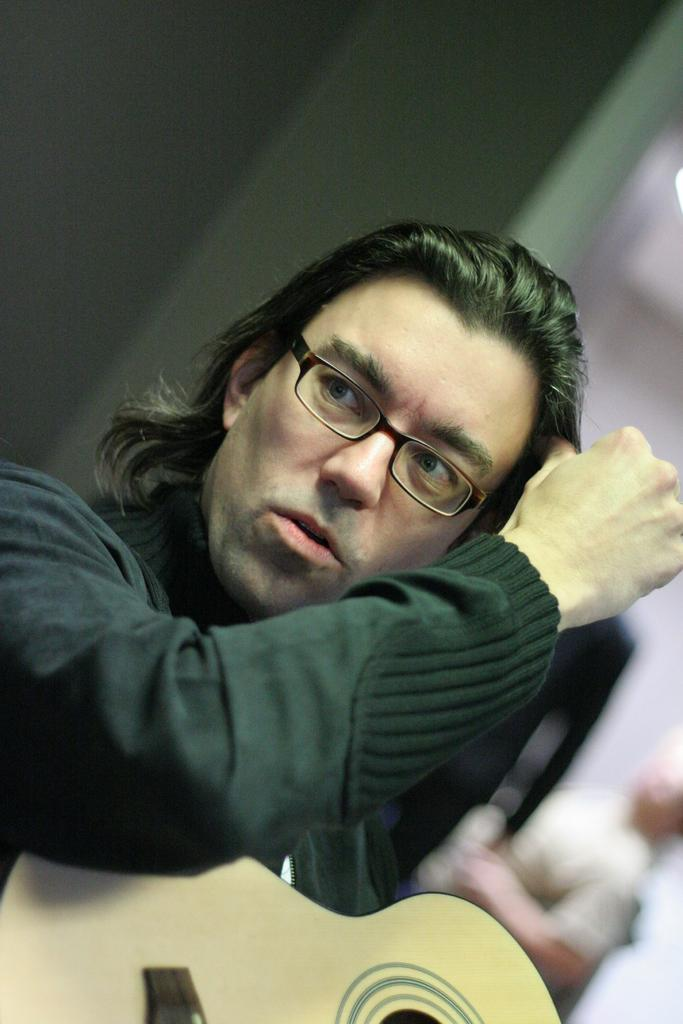Who is the main subject in the image? There is a man in the image. What is the man doing in the image? The man is seated in the image. What object is the man holding in the image? The man is holding a guitar in the image. What accessory is the man wearing in the image? The man is wearing spectacles in the image. What color is the shirt the man is wearing in the image? The man is wearing a black color shirt in the image. What type of knowledge can be gained from the brake in the image? There is no brake present in the image, so no knowledge can be gained from it. 